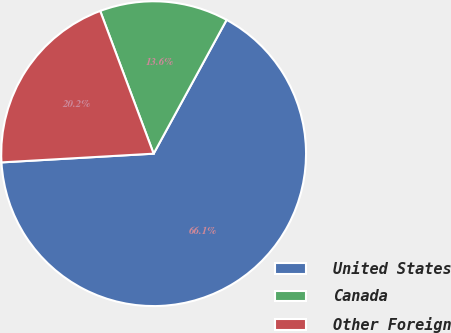Convert chart. <chart><loc_0><loc_0><loc_500><loc_500><pie_chart><fcel>United States<fcel>Canada<fcel>Other Foreign<nl><fcel>66.14%<fcel>13.65%<fcel>20.21%<nl></chart> 